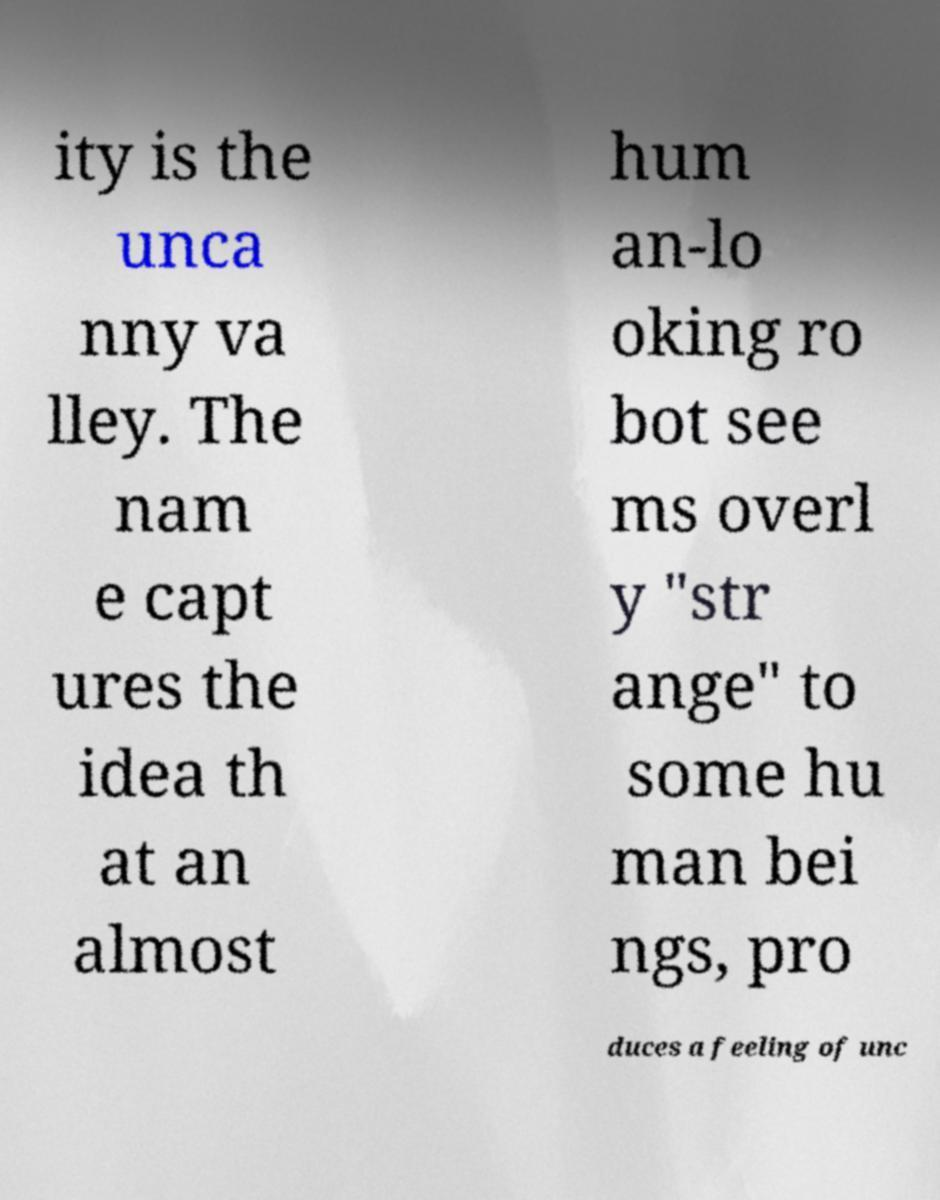For documentation purposes, I need the text within this image transcribed. Could you provide that? ity is the unca nny va lley. The nam e capt ures the idea th at an almost hum an-lo oking ro bot see ms overl y "str ange" to some hu man bei ngs, pro duces a feeling of unc 